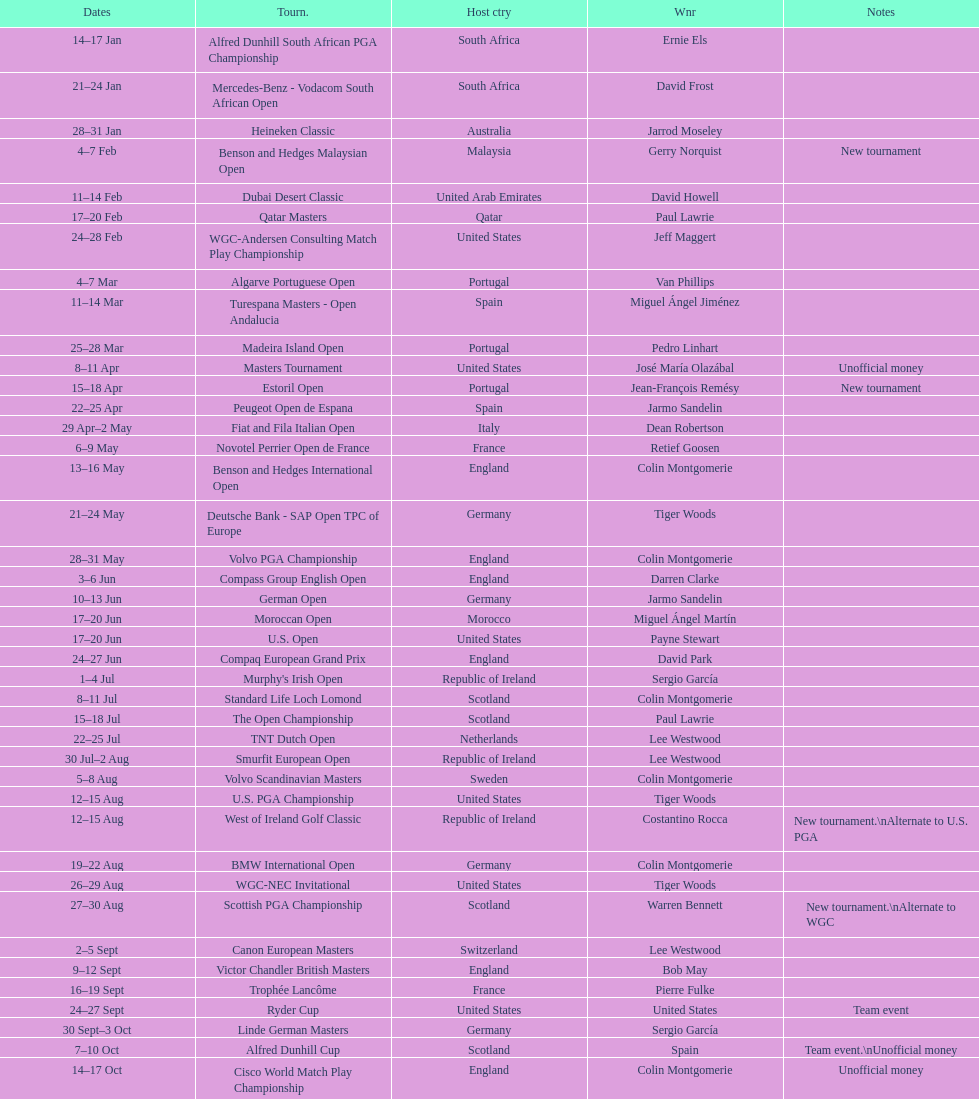Which tournament was later, volvo pga or algarve portuguese open? Volvo PGA. Could you parse the entire table as a dict? {'header': ['Dates', 'Tourn.', 'Host ctry', 'Wnr', 'Notes'], 'rows': [['14–17\xa0Jan', 'Alfred Dunhill South African PGA Championship', 'South Africa', 'Ernie Els', ''], ['21–24\xa0Jan', 'Mercedes-Benz - Vodacom South African Open', 'South Africa', 'David Frost', ''], ['28–31\xa0Jan', 'Heineken Classic', 'Australia', 'Jarrod Moseley', ''], ['4–7\xa0Feb', 'Benson and Hedges Malaysian Open', 'Malaysia', 'Gerry Norquist', 'New tournament'], ['11–14\xa0Feb', 'Dubai Desert Classic', 'United Arab Emirates', 'David Howell', ''], ['17–20\xa0Feb', 'Qatar Masters', 'Qatar', 'Paul Lawrie', ''], ['24–28\xa0Feb', 'WGC-Andersen Consulting Match Play Championship', 'United States', 'Jeff Maggert', ''], ['4–7\xa0Mar', 'Algarve Portuguese Open', 'Portugal', 'Van Phillips', ''], ['11–14\xa0Mar', 'Turespana Masters - Open Andalucia', 'Spain', 'Miguel Ángel Jiménez', ''], ['25–28\xa0Mar', 'Madeira Island Open', 'Portugal', 'Pedro Linhart', ''], ['8–11\xa0Apr', 'Masters Tournament', 'United States', 'José María Olazábal', 'Unofficial money'], ['15–18\xa0Apr', 'Estoril Open', 'Portugal', 'Jean-François Remésy', 'New tournament'], ['22–25\xa0Apr', 'Peugeot Open de Espana', 'Spain', 'Jarmo Sandelin', ''], ['29\xa0Apr–2\xa0May', 'Fiat and Fila Italian Open', 'Italy', 'Dean Robertson', ''], ['6–9\xa0May', 'Novotel Perrier Open de France', 'France', 'Retief Goosen', ''], ['13–16\xa0May', 'Benson and Hedges International Open', 'England', 'Colin Montgomerie', ''], ['21–24\xa0May', 'Deutsche Bank - SAP Open TPC of Europe', 'Germany', 'Tiger Woods', ''], ['28–31\xa0May', 'Volvo PGA Championship', 'England', 'Colin Montgomerie', ''], ['3–6\xa0Jun', 'Compass Group English Open', 'England', 'Darren Clarke', ''], ['10–13\xa0Jun', 'German Open', 'Germany', 'Jarmo Sandelin', ''], ['17–20\xa0Jun', 'Moroccan Open', 'Morocco', 'Miguel Ángel Martín', ''], ['17–20\xa0Jun', 'U.S. Open', 'United States', 'Payne Stewart', ''], ['24–27\xa0Jun', 'Compaq European Grand Prix', 'England', 'David Park', ''], ['1–4\xa0Jul', "Murphy's Irish Open", 'Republic of Ireland', 'Sergio García', ''], ['8–11\xa0Jul', 'Standard Life Loch Lomond', 'Scotland', 'Colin Montgomerie', ''], ['15–18\xa0Jul', 'The Open Championship', 'Scotland', 'Paul Lawrie', ''], ['22–25\xa0Jul', 'TNT Dutch Open', 'Netherlands', 'Lee Westwood', ''], ['30\xa0Jul–2\xa0Aug', 'Smurfit European Open', 'Republic of Ireland', 'Lee Westwood', ''], ['5–8\xa0Aug', 'Volvo Scandinavian Masters', 'Sweden', 'Colin Montgomerie', ''], ['12–15\xa0Aug', 'U.S. PGA Championship', 'United States', 'Tiger Woods', ''], ['12–15\xa0Aug', 'West of Ireland Golf Classic', 'Republic of Ireland', 'Costantino Rocca', 'New tournament.\\nAlternate to U.S. PGA'], ['19–22\xa0Aug', 'BMW International Open', 'Germany', 'Colin Montgomerie', ''], ['26–29\xa0Aug', 'WGC-NEC Invitational', 'United States', 'Tiger Woods', ''], ['27–30\xa0Aug', 'Scottish PGA Championship', 'Scotland', 'Warren Bennett', 'New tournament.\\nAlternate to WGC'], ['2–5\xa0Sept', 'Canon European Masters', 'Switzerland', 'Lee Westwood', ''], ['9–12\xa0Sept', 'Victor Chandler British Masters', 'England', 'Bob May', ''], ['16–19\xa0Sept', 'Trophée Lancôme', 'France', 'Pierre Fulke', ''], ['24–27\xa0Sept', 'Ryder Cup', 'United States', 'United States', 'Team event'], ['30\xa0Sept–3\xa0Oct', 'Linde German Masters', 'Germany', 'Sergio García', ''], ['7–10\xa0Oct', 'Alfred Dunhill Cup', 'Scotland', 'Spain', 'Team event.\\nUnofficial money'], ['14–17\xa0Oct', 'Cisco World Match Play Championship', 'England', 'Colin Montgomerie', 'Unofficial money'], ['14–17\xa0Oct', 'Sarazen World Open', 'Spain', 'Thomas Bjørn', 'New tournament'], ['21–24\xa0Oct', 'Belgacom Open', 'Belgium', 'Robert Karlsson', ''], ['28–31\xa0Oct', 'Volvo Masters', 'Spain', 'Miguel Ángel Jiménez', ''], ['4–7\xa0Nov', 'WGC-American Express Championship', 'Spain', 'Tiger Woods', ''], ['18–21\xa0Nov', 'World Cup of Golf', 'Malaysia', 'United States', 'Team event.\\nUnofficial money']]} 